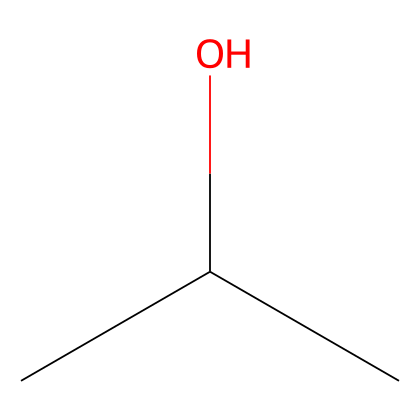What is the full name of this chemical? The SMILES representation "CC(C)O" corresponds to isopropyl alcohol, which is indicated by the structure that contains three carbon atoms and a hydroxyl group.
Answer: isopropyl alcohol How many carbon atoms are in isopropyl alcohol? The chemical structure reveals three carbon atoms (C) as seen from the portion "CC(C)" in the SMILES, signifying that there are three connections representing carbon atoms.
Answer: three What type of functional group is present in isopropyl alcohol? The presence of the hydroxyl (-OH) group attached to a carbon indicates that isopropyl alcohol has an alcohol functional group.
Answer: alcohol Can isopropyl alcohol act as a solvent? The structure shows that isopropyl alcohol is a polar molecule, making it effective as a solvent for non-polar and polar substances, hence confirming it can function as a solvent.
Answer: yes How many hydrogen atoms are connected to carbon in isopropyl alcohol? In the structure of isopropyl alcohol, there are seven hydrogen atoms in total, where each carbon atom is saturated with hydrogen, minus the hydroxyl group bonded to one carbon.
Answer: seven What makes isopropyl alcohol effective for cleaning touchscreens? Its ability to dissolve oils and residues on touchscreens due to its polar nature and the presence of the hydroxyl group contributes to its effectiveness in cleaning applications.
Answer: polar nature What is the boiling point range of isopropyl alcohol? Isopropyl alcohol typically has a boiling point range of around 82 to 83 degrees Celsius, which can be inferred from its molecular weight and structure.
Answer: 82-83 degrees Celsius 